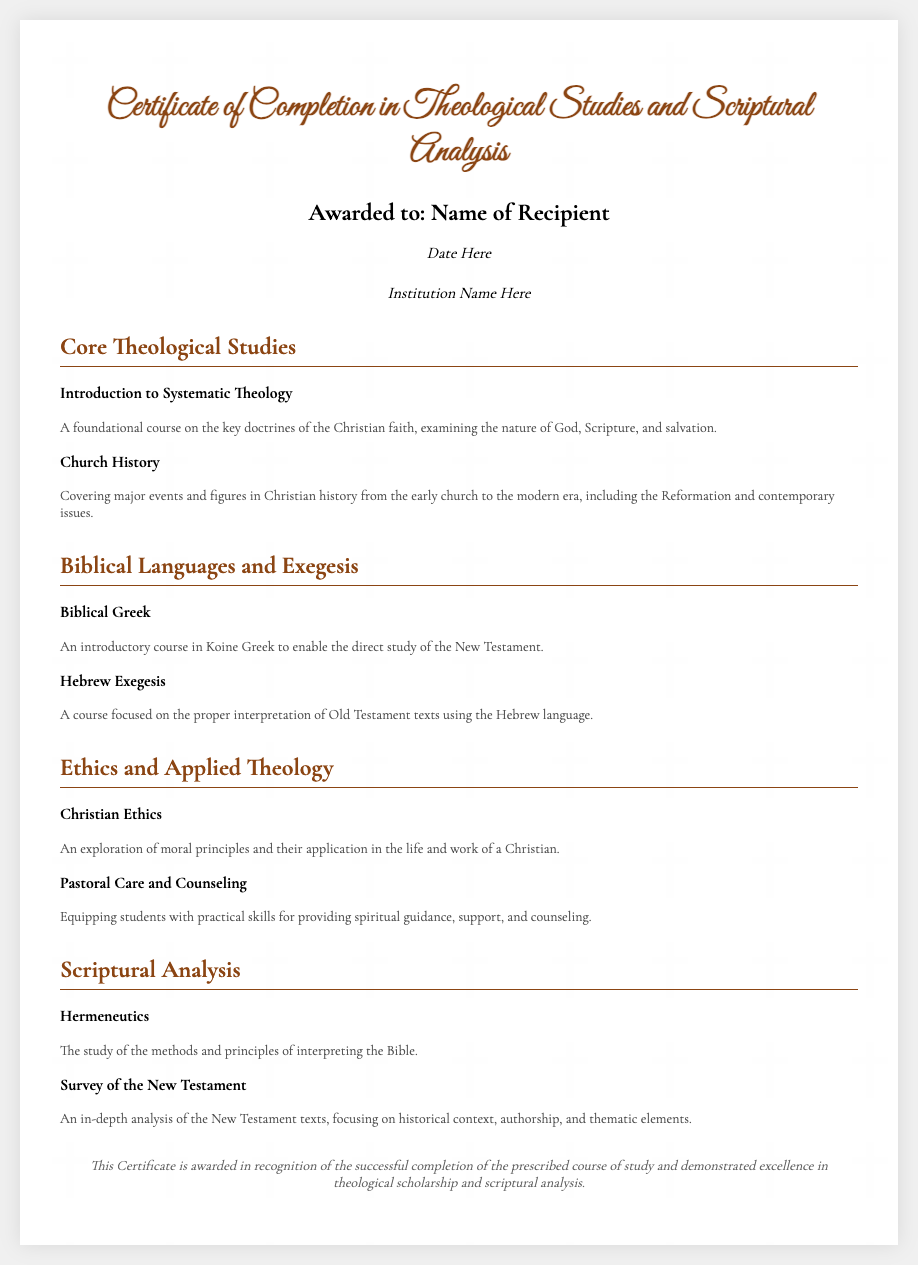What is the title of the certificate? The title of the certificate is prominently displayed at the top of the document.
Answer: Certificate of Completion in Theological Studies and Scriptural Analysis Who is the recipient of the certificate? The recipient's name is mentioned in a dedicated section of the document.
Answer: Name of Recipient What is the date of the award? The date is included below the recipient's name in the document.
Answer: Date Here What institution awarded this certificate? The awarding institution's name is indicated in a specific line in the document.
Answer: Institution Name Here What course covers key doctrines of the Christian faith? The course title is part of the Core Theological Studies section of the document.
Answer: Introduction to Systematic Theology Which biblical language is introduced in the document? The document lists an introductory course for a biblical language.
Answer: Biblical Greek What ethical principle course is mentioned? The name of the course focused on ethics appears under the Ethics and Applied Theology section.
Answer: Christian Ethics What is the focus of the course "Hermeneutics"? The document provides a brief course description about its content.
Answer: Interpreting the Bible How is excellence recognized in this certificate? The footer of the certificate outlines the context for the award recognition.
Answer: Successful completion of the prescribed course of study and demonstrated excellence in theological scholarship and scriptural analysis 